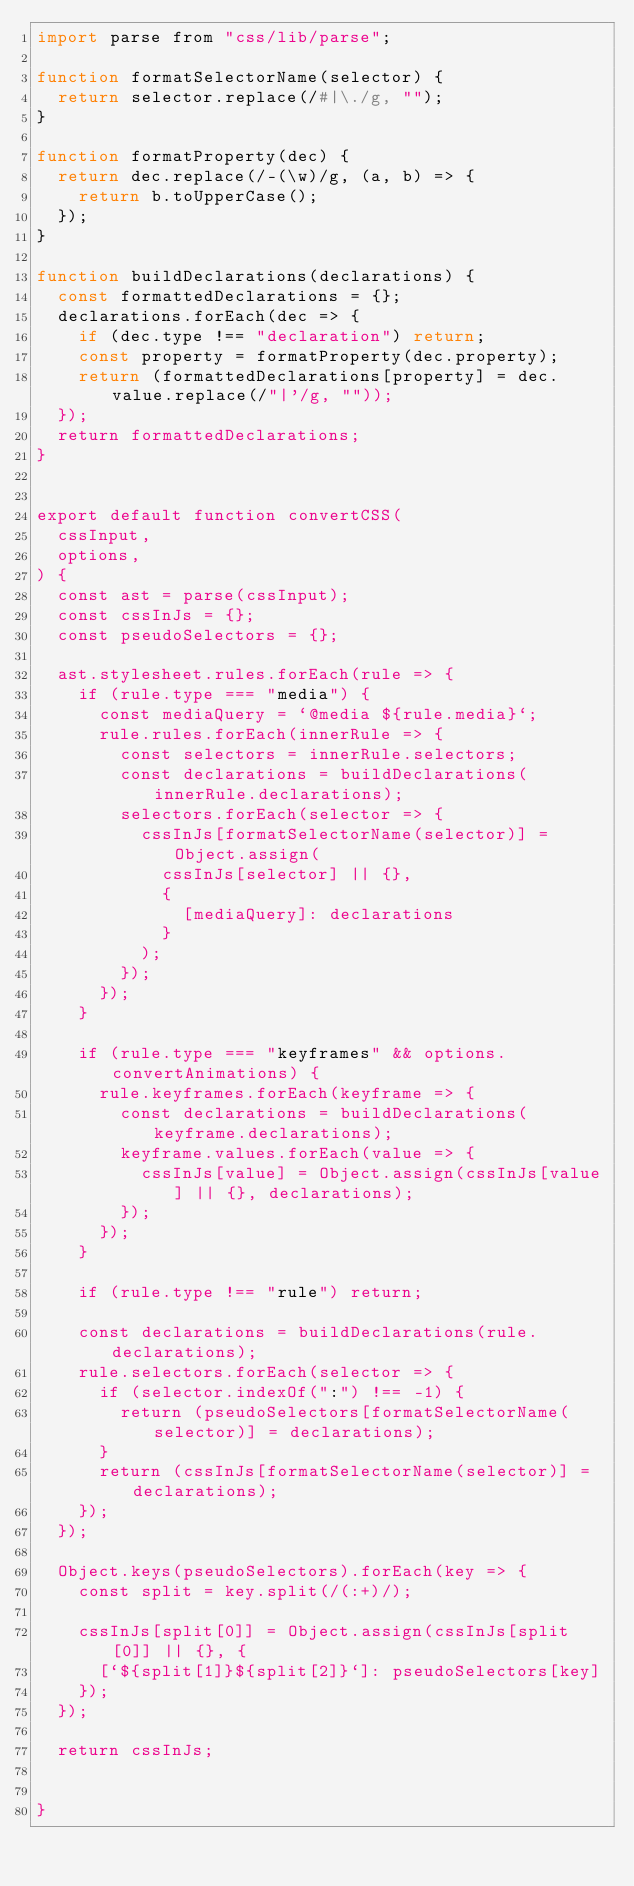<code> <loc_0><loc_0><loc_500><loc_500><_JavaScript_>import parse from "css/lib/parse";

function formatSelectorName(selector) {
  return selector.replace(/#|\./g, "");
}

function formatProperty(dec) {
  return dec.replace(/-(\w)/g, (a, b) => {
    return b.toUpperCase();
  });
}

function buildDeclarations(declarations) {
  const formattedDeclarations = {};
  declarations.forEach(dec => {
    if (dec.type !== "declaration") return;
    const property = formatProperty(dec.property);
    return (formattedDeclarations[property] = dec.value.replace(/"|'/g, ""));
  });
  return formattedDeclarations;
}


export default function convertCSS(
  cssInput,
  options,
) {
  const ast = parse(cssInput);
  const cssInJs = {};
  const pseudoSelectors = {};

  ast.stylesheet.rules.forEach(rule => {
    if (rule.type === "media") {
      const mediaQuery = `@media ${rule.media}`;
      rule.rules.forEach(innerRule => {
        const selectors = innerRule.selectors;
        const declarations = buildDeclarations(innerRule.declarations);
        selectors.forEach(selector => {
          cssInJs[formatSelectorName(selector)] = Object.assign(
            cssInJs[selector] || {},
            {
              [mediaQuery]: declarations
            }
          );
        });
      });
    }

    if (rule.type === "keyframes" && options.convertAnimations) {
      rule.keyframes.forEach(keyframe => {
        const declarations = buildDeclarations(keyframe.declarations);
        keyframe.values.forEach(value => {
          cssInJs[value] = Object.assign(cssInJs[value] || {}, declarations);
        });
      });
    }

    if (rule.type !== "rule") return;

    const declarations = buildDeclarations(rule.declarations);
    rule.selectors.forEach(selector => {
      if (selector.indexOf(":") !== -1) {
        return (pseudoSelectors[formatSelectorName(selector)] = declarations);
      }
      return (cssInJs[formatSelectorName(selector)] = declarations);
    });
  });

  Object.keys(pseudoSelectors).forEach(key => {
    const split = key.split(/(:+)/);

    cssInJs[split[0]] = Object.assign(cssInJs[split[0]] || {}, {
      [`${split[1]}${split[2]}`]: pseudoSelectors[key]
    });
  });

  return cssInJs;


}</code> 